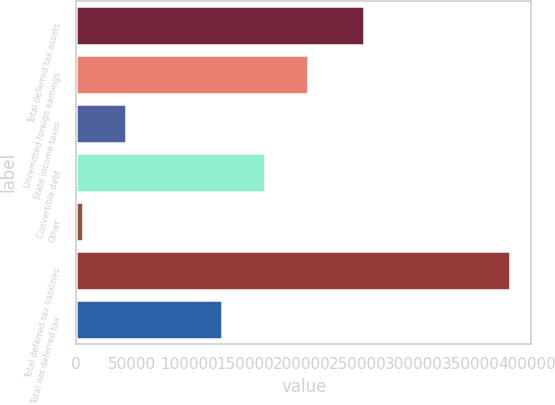<chart> <loc_0><loc_0><loc_500><loc_500><bar_chart><fcel>Total deferred tax assets<fcel>Unremitted foreign earnings<fcel>State income taxes<fcel>Convertible debt<fcel>Other<fcel>Total deferred tax liabilities<fcel>Total net deferred tax<nl><fcel>255676<fcel>205877<fcel>43978.3<fcel>167985<fcel>6086<fcel>385009<fcel>129333<nl></chart> 